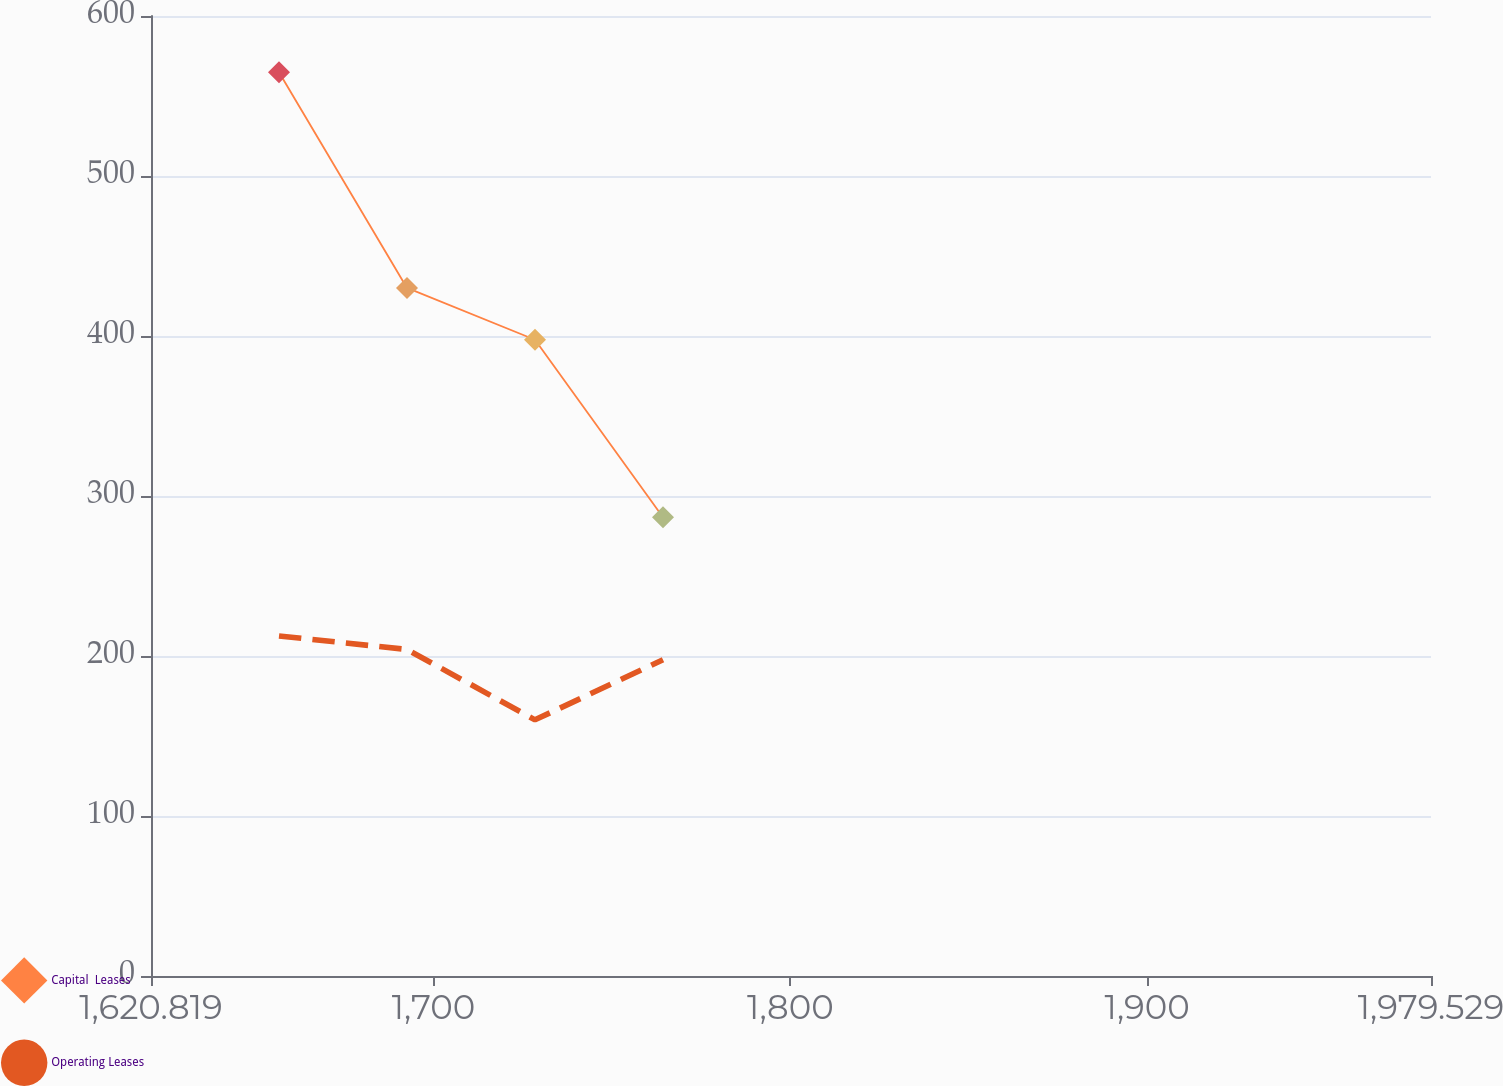Convert chart. <chart><loc_0><loc_0><loc_500><loc_500><line_chart><ecel><fcel>Capital  Leases<fcel>Operating Leases<nl><fcel>1656.69<fcel>564.88<fcel>212.55<nl><fcel>1692.56<fcel>430.05<fcel>204.09<nl><fcel>1728.43<fcel>397.66<fcel>160.1<nl><fcel>1764.3<fcel>286.73<fcel>197.63<nl><fcel>2015.4<fcel>241.03<fcel>224.73<nl></chart> 